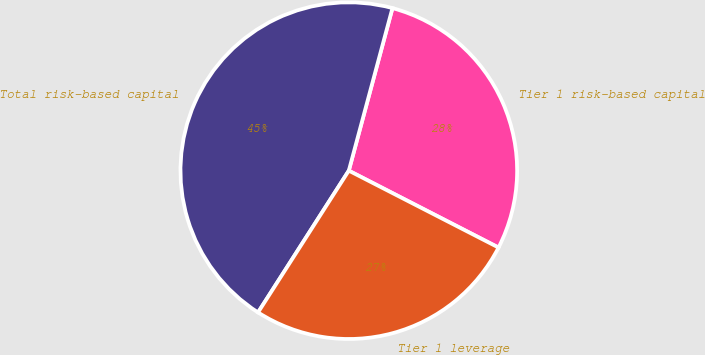<chart> <loc_0><loc_0><loc_500><loc_500><pie_chart><fcel>Tier 1 risk-based capital<fcel>Total risk-based capital<fcel>Tier 1 leverage<nl><fcel>28.37%<fcel>45.11%<fcel>26.51%<nl></chart> 